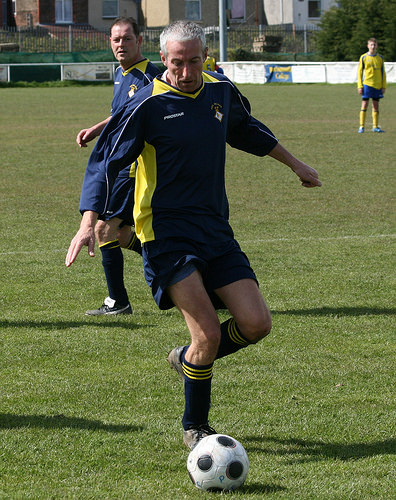<image>
Can you confirm if the man is on the ball? No. The man is not positioned on the ball. They may be near each other, but the man is not supported by or resting on top of the ball. 